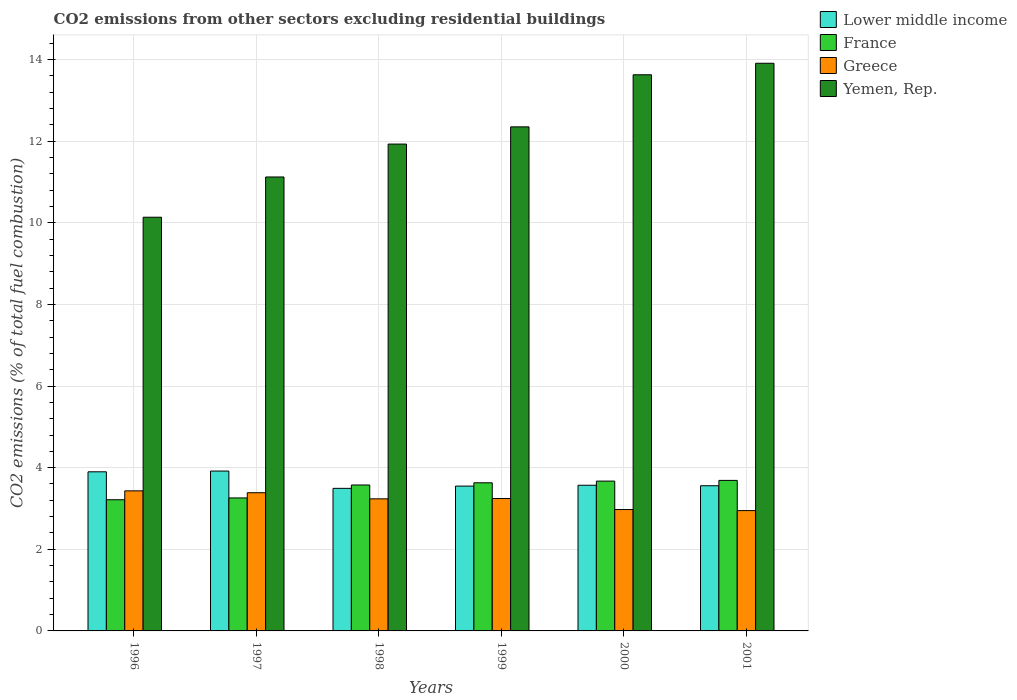How many groups of bars are there?
Keep it short and to the point. 6. Are the number of bars per tick equal to the number of legend labels?
Provide a succinct answer. Yes. How many bars are there on the 5th tick from the left?
Keep it short and to the point. 4. What is the total CO2 emitted in Yemen, Rep. in 2001?
Offer a terse response. 13.91. Across all years, what is the maximum total CO2 emitted in Yemen, Rep.?
Your answer should be very brief. 13.91. Across all years, what is the minimum total CO2 emitted in Greece?
Make the answer very short. 2.95. In which year was the total CO2 emitted in Yemen, Rep. maximum?
Your answer should be very brief. 2001. What is the total total CO2 emitted in Greece in the graph?
Your answer should be very brief. 19.22. What is the difference between the total CO2 emitted in Greece in 2000 and that in 2001?
Offer a terse response. 0.03. What is the difference between the total CO2 emitted in Greece in 2001 and the total CO2 emitted in France in 1999?
Offer a very short reply. -0.68. What is the average total CO2 emitted in Lower middle income per year?
Give a very brief answer. 3.66. In the year 2001, what is the difference between the total CO2 emitted in Greece and total CO2 emitted in France?
Your response must be concise. -0.74. What is the ratio of the total CO2 emitted in Lower middle income in 1999 to that in 2000?
Keep it short and to the point. 0.99. Is the difference between the total CO2 emitted in Greece in 1997 and 2001 greater than the difference between the total CO2 emitted in France in 1997 and 2001?
Provide a succinct answer. Yes. What is the difference between the highest and the second highest total CO2 emitted in Greece?
Your answer should be very brief. 0.05. What is the difference between the highest and the lowest total CO2 emitted in France?
Ensure brevity in your answer.  0.47. In how many years, is the total CO2 emitted in Yemen, Rep. greater than the average total CO2 emitted in Yemen, Rep. taken over all years?
Your answer should be compact. 3. Is the sum of the total CO2 emitted in France in 2000 and 2001 greater than the maximum total CO2 emitted in Yemen, Rep. across all years?
Your response must be concise. No. What does the 1st bar from the right in 1997 represents?
Provide a short and direct response. Yemen, Rep. How many bars are there?
Provide a short and direct response. 24. Are all the bars in the graph horizontal?
Your answer should be compact. No. How many years are there in the graph?
Your answer should be compact. 6. What is the difference between two consecutive major ticks on the Y-axis?
Ensure brevity in your answer.  2. Are the values on the major ticks of Y-axis written in scientific E-notation?
Provide a short and direct response. No. Does the graph contain any zero values?
Provide a succinct answer. No. Where does the legend appear in the graph?
Keep it short and to the point. Top right. How many legend labels are there?
Offer a terse response. 4. What is the title of the graph?
Offer a very short reply. CO2 emissions from other sectors excluding residential buildings. Does "Malaysia" appear as one of the legend labels in the graph?
Give a very brief answer. No. What is the label or title of the X-axis?
Make the answer very short. Years. What is the label or title of the Y-axis?
Your response must be concise. CO2 emissions (% of total fuel combustion). What is the CO2 emissions (% of total fuel combustion) of Lower middle income in 1996?
Ensure brevity in your answer.  3.9. What is the CO2 emissions (% of total fuel combustion) of France in 1996?
Your response must be concise. 3.21. What is the CO2 emissions (% of total fuel combustion) in Greece in 1996?
Give a very brief answer. 3.43. What is the CO2 emissions (% of total fuel combustion) in Yemen, Rep. in 1996?
Give a very brief answer. 10.14. What is the CO2 emissions (% of total fuel combustion) in Lower middle income in 1997?
Ensure brevity in your answer.  3.92. What is the CO2 emissions (% of total fuel combustion) of France in 1997?
Offer a very short reply. 3.26. What is the CO2 emissions (% of total fuel combustion) in Greece in 1997?
Provide a short and direct response. 3.39. What is the CO2 emissions (% of total fuel combustion) in Yemen, Rep. in 1997?
Keep it short and to the point. 11.12. What is the CO2 emissions (% of total fuel combustion) of Lower middle income in 1998?
Your answer should be compact. 3.49. What is the CO2 emissions (% of total fuel combustion) of France in 1998?
Provide a short and direct response. 3.58. What is the CO2 emissions (% of total fuel combustion) of Greece in 1998?
Keep it short and to the point. 3.24. What is the CO2 emissions (% of total fuel combustion) of Yemen, Rep. in 1998?
Offer a terse response. 11.93. What is the CO2 emissions (% of total fuel combustion) in Lower middle income in 1999?
Give a very brief answer. 3.55. What is the CO2 emissions (% of total fuel combustion) in France in 1999?
Your response must be concise. 3.63. What is the CO2 emissions (% of total fuel combustion) of Greece in 1999?
Your answer should be very brief. 3.24. What is the CO2 emissions (% of total fuel combustion) of Yemen, Rep. in 1999?
Offer a very short reply. 12.35. What is the CO2 emissions (% of total fuel combustion) in Lower middle income in 2000?
Provide a short and direct response. 3.57. What is the CO2 emissions (% of total fuel combustion) in France in 2000?
Make the answer very short. 3.67. What is the CO2 emissions (% of total fuel combustion) of Greece in 2000?
Your answer should be compact. 2.97. What is the CO2 emissions (% of total fuel combustion) in Yemen, Rep. in 2000?
Keep it short and to the point. 13.63. What is the CO2 emissions (% of total fuel combustion) of Lower middle income in 2001?
Provide a succinct answer. 3.56. What is the CO2 emissions (% of total fuel combustion) of France in 2001?
Keep it short and to the point. 3.69. What is the CO2 emissions (% of total fuel combustion) of Greece in 2001?
Your answer should be compact. 2.95. What is the CO2 emissions (% of total fuel combustion) of Yemen, Rep. in 2001?
Make the answer very short. 13.91. Across all years, what is the maximum CO2 emissions (% of total fuel combustion) in Lower middle income?
Give a very brief answer. 3.92. Across all years, what is the maximum CO2 emissions (% of total fuel combustion) of France?
Keep it short and to the point. 3.69. Across all years, what is the maximum CO2 emissions (% of total fuel combustion) in Greece?
Offer a very short reply. 3.43. Across all years, what is the maximum CO2 emissions (% of total fuel combustion) of Yemen, Rep.?
Your response must be concise. 13.91. Across all years, what is the minimum CO2 emissions (% of total fuel combustion) of Lower middle income?
Offer a very short reply. 3.49. Across all years, what is the minimum CO2 emissions (% of total fuel combustion) in France?
Keep it short and to the point. 3.21. Across all years, what is the minimum CO2 emissions (% of total fuel combustion) of Greece?
Offer a terse response. 2.95. Across all years, what is the minimum CO2 emissions (% of total fuel combustion) in Yemen, Rep.?
Ensure brevity in your answer.  10.14. What is the total CO2 emissions (% of total fuel combustion) of Lower middle income in the graph?
Provide a short and direct response. 21.98. What is the total CO2 emissions (% of total fuel combustion) in France in the graph?
Ensure brevity in your answer.  21.04. What is the total CO2 emissions (% of total fuel combustion) of Greece in the graph?
Offer a very short reply. 19.22. What is the total CO2 emissions (% of total fuel combustion) of Yemen, Rep. in the graph?
Ensure brevity in your answer.  73.07. What is the difference between the CO2 emissions (% of total fuel combustion) in Lower middle income in 1996 and that in 1997?
Give a very brief answer. -0.02. What is the difference between the CO2 emissions (% of total fuel combustion) of France in 1996 and that in 1997?
Provide a succinct answer. -0.04. What is the difference between the CO2 emissions (% of total fuel combustion) of Greece in 1996 and that in 1997?
Ensure brevity in your answer.  0.05. What is the difference between the CO2 emissions (% of total fuel combustion) of Yemen, Rep. in 1996 and that in 1997?
Ensure brevity in your answer.  -0.99. What is the difference between the CO2 emissions (% of total fuel combustion) in Lower middle income in 1996 and that in 1998?
Make the answer very short. 0.41. What is the difference between the CO2 emissions (% of total fuel combustion) of France in 1996 and that in 1998?
Keep it short and to the point. -0.36. What is the difference between the CO2 emissions (% of total fuel combustion) in Greece in 1996 and that in 1998?
Make the answer very short. 0.2. What is the difference between the CO2 emissions (% of total fuel combustion) in Yemen, Rep. in 1996 and that in 1998?
Make the answer very short. -1.79. What is the difference between the CO2 emissions (% of total fuel combustion) in Lower middle income in 1996 and that in 1999?
Offer a very short reply. 0.35. What is the difference between the CO2 emissions (% of total fuel combustion) of France in 1996 and that in 1999?
Keep it short and to the point. -0.42. What is the difference between the CO2 emissions (% of total fuel combustion) in Greece in 1996 and that in 1999?
Keep it short and to the point. 0.19. What is the difference between the CO2 emissions (% of total fuel combustion) in Yemen, Rep. in 1996 and that in 1999?
Provide a succinct answer. -2.21. What is the difference between the CO2 emissions (% of total fuel combustion) in Lower middle income in 1996 and that in 2000?
Keep it short and to the point. 0.33. What is the difference between the CO2 emissions (% of total fuel combustion) in France in 1996 and that in 2000?
Make the answer very short. -0.46. What is the difference between the CO2 emissions (% of total fuel combustion) of Greece in 1996 and that in 2000?
Provide a short and direct response. 0.46. What is the difference between the CO2 emissions (% of total fuel combustion) of Yemen, Rep. in 1996 and that in 2000?
Ensure brevity in your answer.  -3.49. What is the difference between the CO2 emissions (% of total fuel combustion) of Lower middle income in 1996 and that in 2001?
Your response must be concise. 0.34. What is the difference between the CO2 emissions (% of total fuel combustion) in France in 1996 and that in 2001?
Keep it short and to the point. -0.47. What is the difference between the CO2 emissions (% of total fuel combustion) of Greece in 1996 and that in 2001?
Offer a very short reply. 0.48. What is the difference between the CO2 emissions (% of total fuel combustion) in Yemen, Rep. in 1996 and that in 2001?
Provide a short and direct response. -3.77. What is the difference between the CO2 emissions (% of total fuel combustion) in Lower middle income in 1997 and that in 1998?
Your answer should be very brief. 0.42. What is the difference between the CO2 emissions (% of total fuel combustion) in France in 1997 and that in 1998?
Offer a terse response. -0.32. What is the difference between the CO2 emissions (% of total fuel combustion) in Greece in 1997 and that in 1998?
Keep it short and to the point. 0.15. What is the difference between the CO2 emissions (% of total fuel combustion) in Yemen, Rep. in 1997 and that in 1998?
Provide a succinct answer. -0.81. What is the difference between the CO2 emissions (% of total fuel combustion) of Lower middle income in 1997 and that in 1999?
Your answer should be compact. 0.37. What is the difference between the CO2 emissions (% of total fuel combustion) in France in 1997 and that in 1999?
Ensure brevity in your answer.  -0.37. What is the difference between the CO2 emissions (% of total fuel combustion) in Greece in 1997 and that in 1999?
Keep it short and to the point. 0.14. What is the difference between the CO2 emissions (% of total fuel combustion) of Yemen, Rep. in 1997 and that in 1999?
Your answer should be compact. -1.23. What is the difference between the CO2 emissions (% of total fuel combustion) in Lower middle income in 1997 and that in 2000?
Give a very brief answer. 0.35. What is the difference between the CO2 emissions (% of total fuel combustion) in France in 1997 and that in 2000?
Give a very brief answer. -0.41. What is the difference between the CO2 emissions (% of total fuel combustion) of Greece in 1997 and that in 2000?
Give a very brief answer. 0.41. What is the difference between the CO2 emissions (% of total fuel combustion) in Yemen, Rep. in 1997 and that in 2000?
Your answer should be very brief. -2.5. What is the difference between the CO2 emissions (% of total fuel combustion) in Lower middle income in 1997 and that in 2001?
Make the answer very short. 0.36. What is the difference between the CO2 emissions (% of total fuel combustion) in France in 1997 and that in 2001?
Provide a succinct answer. -0.43. What is the difference between the CO2 emissions (% of total fuel combustion) of Greece in 1997 and that in 2001?
Offer a very short reply. 0.44. What is the difference between the CO2 emissions (% of total fuel combustion) in Yemen, Rep. in 1997 and that in 2001?
Give a very brief answer. -2.79. What is the difference between the CO2 emissions (% of total fuel combustion) in Lower middle income in 1998 and that in 1999?
Provide a succinct answer. -0.06. What is the difference between the CO2 emissions (% of total fuel combustion) of France in 1998 and that in 1999?
Ensure brevity in your answer.  -0.05. What is the difference between the CO2 emissions (% of total fuel combustion) of Greece in 1998 and that in 1999?
Give a very brief answer. -0.01. What is the difference between the CO2 emissions (% of total fuel combustion) of Yemen, Rep. in 1998 and that in 1999?
Provide a short and direct response. -0.42. What is the difference between the CO2 emissions (% of total fuel combustion) in Lower middle income in 1998 and that in 2000?
Provide a succinct answer. -0.08. What is the difference between the CO2 emissions (% of total fuel combustion) in France in 1998 and that in 2000?
Keep it short and to the point. -0.1. What is the difference between the CO2 emissions (% of total fuel combustion) of Greece in 1998 and that in 2000?
Your response must be concise. 0.26. What is the difference between the CO2 emissions (% of total fuel combustion) of Yemen, Rep. in 1998 and that in 2000?
Provide a succinct answer. -1.7. What is the difference between the CO2 emissions (% of total fuel combustion) of Lower middle income in 1998 and that in 2001?
Give a very brief answer. -0.06. What is the difference between the CO2 emissions (% of total fuel combustion) in France in 1998 and that in 2001?
Offer a terse response. -0.11. What is the difference between the CO2 emissions (% of total fuel combustion) of Greece in 1998 and that in 2001?
Offer a terse response. 0.29. What is the difference between the CO2 emissions (% of total fuel combustion) of Yemen, Rep. in 1998 and that in 2001?
Offer a terse response. -1.98. What is the difference between the CO2 emissions (% of total fuel combustion) of Lower middle income in 1999 and that in 2000?
Offer a very short reply. -0.02. What is the difference between the CO2 emissions (% of total fuel combustion) in France in 1999 and that in 2000?
Your answer should be very brief. -0.04. What is the difference between the CO2 emissions (% of total fuel combustion) of Greece in 1999 and that in 2000?
Your answer should be very brief. 0.27. What is the difference between the CO2 emissions (% of total fuel combustion) of Yemen, Rep. in 1999 and that in 2000?
Your response must be concise. -1.28. What is the difference between the CO2 emissions (% of total fuel combustion) of Lower middle income in 1999 and that in 2001?
Make the answer very short. -0.01. What is the difference between the CO2 emissions (% of total fuel combustion) in France in 1999 and that in 2001?
Keep it short and to the point. -0.06. What is the difference between the CO2 emissions (% of total fuel combustion) of Greece in 1999 and that in 2001?
Your answer should be compact. 0.3. What is the difference between the CO2 emissions (% of total fuel combustion) in Yemen, Rep. in 1999 and that in 2001?
Your answer should be compact. -1.56. What is the difference between the CO2 emissions (% of total fuel combustion) of Lower middle income in 2000 and that in 2001?
Provide a succinct answer. 0.01. What is the difference between the CO2 emissions (% of total fuel combustion) in France in 2000 and that in 2001?
Give a very brief answer. -0.02. What is the difference between the CO2 emissions (% of total fuel combustion) of Greece in 2000 and that in 2001?
Give a very brief answer. 0.03. What is the difference between the CO2 emissions (% of total fuel combustion) of Yemen, Rep. in 2000 and that in 2001?
Ensure brevity in your answer.  -0.28. What is the difference between the CO2 emissions (% of total fuel combustion) in Lower middle income in 1996 and the CO2 emissions (% of total fuel combustion) in France in 1997?
Offer a very short reply. 0.64. What is the difference between the CO2 emissions (% of total fuel combustion) in Lower middle income in 1996 and the CO2 emissions (% of total fuel combustion) in Greece in 1997?
Your answer should be very brief. 0.51. What is the difference between the CO2 emissions (% of total fuel combustion) of Lower middle income in 1996 and the CO2 emissions (% of total fuel combustion) of Yemen, Rep. in 1997?
Ensure brevity in your answer.  -7.22. What is the difference between the CO2 emissions (% of total fuel combustion) in France in 1996 and the CO2 emissions (% of total fuel combustion) in Greece in 1997?
Keep it short and to the point. -0.17. What is the difference between the CO2 emissions (% of total fuel combustion) in France in 1996 and the CO2 emissions (% of total fuel combustion) in Yemen, Rep. in 1997?
Make the answer very short. -7.91. What is the difference between the CO2 emissions (% of total fuel combustion) in Greece in 1996 and the CO2 emissions (% of total fuel combustion) in Yemen, Rep. in 1997?
Ensure brevity in your answer.  -7.69. What is the difference between the CO2 emissions (% of total fuel combustion) of Lower middle income in 1996 and the CO2 emissions (% of total fuel combustion) of France in 1998?
Provide a succinct answer. 0.32. What is the difference between the CO2 emissions (% of total fuel combustion) in Lower middle income in 1996 and the CO2 emissions (% of total fuel combustion) in Greece in 1998?
Ensure brevity in your answer.  0.66. What is the difference between the CO2 emissions (% of total fuel combustion) in Lower middle income in 1996 and the CO2 emissions (% of total fuel combustion) in Yemen, Rep. in 1998?
Your response must be concise. -8.03. What is the difference between the CO2 emissions (% of total fuel combustion) of France in 1996 and the CO2 emissions (% of total fuel combustion) of Greece in 1998?
Your answer should be compact. -0.02. What is the difference between the CO2 emissions (% of total fuel combustion) in France in 1996 and the CO2 emissions (% of total fuel combustion) in Yemen, Rep. in 1998?
Offer a very short reply. -8.71. What is the difference between the CO2 emissions (% of total fuel combustion) of Greece in 1996 and the CO2 emissions (% of total fuel combustion) of Yemen, Rep. in 1998?
Your answer should be compact. -8.5. What is the difference between the CO2 emissions (% of total fuel combustion) in Lower middle income in 1996 and the CO2 emissions (% of total fuel combustion) in France in 1999?
Keep it short and to the point. 0.27. What is the difference between the CO2 emissions (% of total fuel combustion) in Lower middle income in 1996 and the CO2 emissions (% of total fuel combustion) in Greece in 1999?
Provide a succinct answer. 0.65. What is the difference between the CO2 emissions (% of total fuel combustion) in Lower middle income in 1996 and the CO2 emissions (% of total fuel combustion) in Yemen, Rep. in 1999?
Ensure brevity in your answer.  -8.45. What is the difference between the CO2 emissions (% of total fuel combustion) of France in 1996 and the CO2 emissions (% of total fuel combustion) of Greece in 1999?
Keep it short and to the point. -0.03. What is the difference between the CO2 emissions (% of total fuel combustion) of France in 1996 and the CO2 emissions (% of total fuel combustion) of Yemen, Rep. in 1999?
Provide a succinct answer. -9.14. What is the difference between the CO2 emissions (% of total fuel combustion) of Greece in 1996 and the CO2 emissions (% of total fuel combustion) of Yemen, Rep. in 1999?
Offer a very short reply. -8.92. What is the difference between the CO2 emissions (% of total fuel combustion) of Lower middle income in 1996 and the CO2 emissions (% of total fuel combustion) of France in 2000?
Provide a succinct answer. 0.23. What is the difference between the CO2 emissions (% of total fuel combustion) in Lower middle income in 1996 and the CO2 emissions (% of total fuel combustion) in Greece in 2000?
Give a very brief answer. 0.92. What is the difference between the CO2 emissions (% of total fuel combustion) in Lower middle income in 1996 and the CO2 emissions (% of total fuel combustion) in Yemen, Rep. in 2000?
Keep it short and to the point. -9.73. What is the difference between the CO2 emissions (% of total fuel combustion) in France in 1996 and the CO2 emissions (% of total fuel combustion) in Greece in 2000?
Keep it short and to the point. 0.24. What is the difference between the CO2 emissions (% of total fuel combustion) of France in 1996 and the CO2 emissions (% of total fuel combustion) of Yemen, Rep. in 2000?
Provide a short and direct response. -10.41. What is the difference between the CO2 emissions (% of total fuel combustion) of Greece in 1996 and the CO2 emissions (% of total fuel combustion) of Yemen, Rep. in 2000?
Give a very brief answer. -10.19. What is the difference between the CO2 emissions (% of total fuel combustion) in Lower middle income in 1996 and the CO2 emissions (% of total fuel combustion) in France in 2001?
Your response must be concise. 0.21. What is the difference between the CO2 emissions (% of total fuel combustion) in Lower middle income in 1996 and the CO2 emissions (% of total fuel combustion) in Greece in 2001?
Keep it short and to the point. 0.95. What is the difference between the CO2 emissions (% of total fuel combustion) of Lower middle income in 1996 and the CO2 emissions (% of total fuel combustion) of Yemen, Rep. in 2001?
Give a very brief answer. -10.01. What is the difference between the CO2 emissions (% of total fuel combustion) in France in 1996 and the CO2 emissions (% of total fuel combustion) in Greece in 2001?
Your answer should be very brief. 0.27. What is the difference between the CO2 emissions (% of total fuel combustion) in France in 1996 and the CO2 emissions (% of total fuel combustion) in Yemen, Rep. in 2001?
Provide a short and direct response. -10.69. What is the difference between the CO2 emissions (% of total fuel combustion) of Greece in 1996 and the CO2 emissions (% of total fuel combustion) of Yemen, Rep. in 2001?
Keep it short and to the point. -10.48. What is the difference between the CO2 emissions (% of total fuel combustion) in Lower middle income in 1997 and the CO2 emissions (% of total fuel combustion) in France in 1998?
Provide a succinct answer. 0.34. What is the difference between the CO2 emissions (% of total fuel combustion) in Lower middle income in 1997 and the CO2 emissions (% of total fuel combustion) in Greece in 1998?
Make the answer very short. 0.68. What is the difference between the CO2 emissions (% of total fuel combustion) in Lower middle income in 1997 and the CO2 emissions (% of total fuel combustion) in Yemen, Rep. in 1998?
Give a very brief answer. -8.01. What is the difference between the CO2 emissions (% of total fuel combustion) in France in 1997 and the CO2 emissions (% of total fuel combustion) in Greece in 1998?
Ensure brevity in your answer.  0.02. What is the difference between the CO2 emissions (% of total fuel combustion) of France in 1997 and the CO2 emissions (% of total fuel combustion) of Yemen, Rep. in 1998?
Give a very brief answer. -8.67. What is the difference between the CO2 emissions (% of total fuel combustion) of Greece in 1997 and the CO2 emissions (% of total fuel combustion) of Yemen, Rep. in 1998?
Provide a succinct answer. -8.54. What is the difference between the CO2 emissions (% of total fuel combustion) in Lower middle income in 1997 and the CO2 emissions (% of total fuel combustion) in France in 1999?
Make the answer very short. 0.29. What is the difference between the CO2 emissions (% of total fuel combustion) in Lower middle income in 1997 and the CO2 emissions (% of total fuel combustion) in Greece in 1999?
Offer a very short reply. 0.67. What is the difference between the CO2 emissions (% of total fuel combustion) of Lower middle income in 1997 and the CO2 emissions (% of total fuel combustion) of Yemen, Rep. in 1999?
Ensure brevity in your answer.  -8.43. What is the difference between the CO2 emissions (% of total fuel combustion) in France in 1997 and the CO2 emissions (% of total fuel combustion) in Greece in 1999?
Your answer should be very brief. 0.01. What is the difference between the CO2 emissions (% of total fuel combustion) of France in 1997 and the CO2 emissions (% of total fuel combustion) of Yemen, Rep. in 1999?
Provide a succinct answer. -9.09. What is the difference between the CO2 emissions (% of total fuel combustion) of Greece in 1997 and the CO2 emissions (% of total fuel combustion) of Yemen, Rep. in 1999?
Give a very brief answer. -8.96. What is the difference between the CO2 emissions (% of total fuel combustion) of Lower middle income in 1997 and the CO2 emissions (% of total fuel combustion) of France in 2000?
Your answer should be very brief. 0.25. What is the difference between the CO2 emissions (% of total fuel combustion) in Lower middle income in 1997 and the CO2 emissions (% of total fuel combustion) in Greece in 2000?
Give a very brief answer. 0.94. What is the difference between the CO2 emissions (% of total fuel combustion) in Lower middle income in 1997 and the CO2 emissions (% of total fuel combustion) in Yemen, Rep. in 2000?
Ensure brevity in your answer.  -9.71. What is the difference between the CO2 emissions (% of total fuel combustion) in France in 1997 and the CO2 emissions (% of total fuel combustion) in Greece in 2000?
Make the answer very short. 0.28. What is the difference between the CO2 emissions (% of total fuel combustion) of France in 1997 and the CO2 emissions (% of total fuel combustion) of Yemen, Rep. in 2000?
Make the answer very short. -10.37. What is the difference between the CO2 emissions (% of total fuel combustion) of Greece in 1997 and the CO2 emissions (% of total fuel combustion) of Yemen, Rep. in 2000?
Your answer should be compact. -10.24. What is the difference between the CO2 emissions (% of total fuel combustion) in Lower middle income in 1997 and the CO2 emissions (% of total fuel combustion) in France in 2001?
Provide a short and direct response. 0.23. What is the difference between the CO2 emissions (% of total fuel combustion) in Lower middle income in 1997 and the CO2 emissions (% of total fuel combustion) in Greece in 2001?
Give a very brief answer. 0.97. What is the difference between the CO2 emissions (% of total fuel combustion) of Lower middle income in 1997 and the CO2 emissions (% of total fuel combustion) of Yemen, Rep. in 2001?
Provide a short and direct response. -9.99. What is the difference between the CO2 emissions (% of total fuel combustion) in France in 1997 and the CO2 emissions (% of total fuel combustion) in Greece in 2001?
Provide a succinct answer. 0.31. What is the difference between the CO2 emissions (% of total fuel combustion) of France in 1997 and the CO2 emissions (% of total fuel combustion) of Yemen, Rep. in 2001?
Offer a terse response. -10.65. What is the difference between the CO2 emissions (% of total fuel combustion) of Greece in 1997 and the CO2 emissions (% of total fuel combustion) of Yemen, Rep. in 2001?
Provide a succinct answer. -10.52. What is the difference between the CO2 emissions (% of total fuel combustion) of Lower middle income in 1998 and the CO2 emissions (% of total fuel combustion) of France in 1999?
Keep it short and to the point. -0.14. What is the difference between the CO2 emissions (% of total fuel combustion) of Lower middle income in 1998 and the CO2 emissions (% of total fuel combustion) of Greece in 1999?
Make the answer very short. 0.25. What is the difference between the CO2 emissions (% of total fuel combustion) in Lower middle income in 1998 and the CO2 emissions (% of total fuel combustion) in Yemen, Rep. in 1999?
Offer a terse response. -8.86. What is the difference between the CO2 emissions (% of total fuel combustion) in France in 1998 and the CO2 emissions (% of total fuel combustion) in Greece in 1999?
Your answer should be very brief. 0.33. What is the difference between the CO2 emissions (% of total fuel combustion) in France in 1998 and the CO2 emissions (% of total fuel combustion) in Yemen, Rep. in 1999?
Keep it short and to the point. -8.77. What is the difference between the CO2 emissions (% of total fuel combustion) in Greece in 1998 and the CO2 emissions (% of total fuel combustion) in Yemen, Rep. in 1999?
Offer a terse response. -9.11. What is the difference between the CO2 emissions (% of total fuel combustion) in Lower middle income in 1998 and the CO2 emissions (% of total fuel combustion) in France in 2000?
Keep it short and to the point. -0.18. What is the difference between the CO2 emissions (% of total fuel combustion) in Lower middle income in 1998 and the CO2 emissions (% of total fuel combustion) in Greece in 2000?
Provide a short and direct response. 0.52. What is the difference between the CO2 emissions (% of total fuel combustion) in Lower middle income in 1998 and the CO2 emissions (% of total fuel combustion) in Yemen, Rep. in 2000?
Give a very brief answer. -10.13. What is the difference between the CO2 emissions (% of total fuel combustion) in France in 1998 and the CO2 emissions (% of total fuel combustion) in Greece in 2000?
Your answer should be compact. 0.6. What is the difference between the CO2 emissions (% of total fuel combustion) of France in 1998 and the CO2 emissions (% of total fuel combustion) of Yemen, Rep. in 2000?
Offer a terse response. -10.05. What is the difference between the CO2 emissions (% of total fuel combustion) of Greece in 1998 and the CO2 emissions (% of total fuel combustion) of Yemen, Rep. in 2000?
Your answer should be very brief. -10.39. What is the difference between the CO2 emissions (% of total fuel combustion) in Lower middle income in 1998 and the CO2 emissions (% of total fuel combustion) in France in 2001?
Your answer should be very brief. -0.19. What is the difference between the CO2 emissions (% of total fuel combustion) of Lower middle income in 1998 and the CO2 emissions (% of total fuel combustion) of Greece in 2001?
Keep it short and to the point. 0.55. What is the difference between the CO2 emissions (% of total fuel combustion) in Lower middle income in 1998 and the CO2 emissions (% of total fuel combustion) in Yemen, Rep. in 2001?
Ensure brevity in your answer.  -10.42. What is the difference between the CO2 emissions (% of total fuel combustion) of France in 1998 and the CO2 emissions (% of total fuel combustion) of Greece in 2001?
Make the answer very short. 0.63. What is the difference between the CO2 emissions (% of total fuel combustion) in France in 1998 and the CO2 emissions (% of total fuel combustion) in Yemen, Rep. in 2001?
Give a very brief answer. -10.33. What is the difference between the CO2 emissions (% of total fuel combustion) in Greece in 1998 and the CO2 emissions (% of total fuel combustion) in Yemen, Rep. in 2001?
Give a very brief answer. -10.67. What is the difference between the CO2 emissions (% of total fuel combustion) of Lower middle income in 1999 and the CO2 emissions (% of total fuel combustion) of France in 2000?
Ensure brevity in your answer.  -0.12. What is the difference between the CO2 emissions (% of total fuel combustion) of Lower middle income in 1999 and the CO2 emissions (% of total fuel combustion) of Greece in 2000?
Offer a very short reply. 0.57. What is the difference between the CO2 emissions (% of total fuel combustion) of Lower middle income in 1999 and the CO2 emissions (% of total fuel combustion) of Yemen, Rep. in 2000?
Provide a short and direct response. -10.08. What is the difference between the CO2 emissions (% of total fuel combustion) of France in 1999 and the CO2 emissions (% of total fuel combustion) of Greece in 2000?
Your answer should be compact. 0.66. What is the difference between the CO2 emissions (% of total fuel combustion) of France in 1999 and the CO2 emissions (% of total fuel combustion) of Yemen, Rep. in 2000?
Give a very brief answer. -10. What is the difference between the CO2 emissions (% of total fuel combustion) of Greece in 1999 and the CO2 emissions (% of total fuel combustion) of Yemen, Rep. in 2000?
Keep it short and to the point. -10.38. What is the difference between the CO2 emissions (% of total fuel combustion) in Lower middle income in 1999 and the CO2 emissions (% of total fuel combustion) in France in 2001?
Provide a short and direct response. -0.14. What is the difference between the CO2 emissions (% of total fuel combustion) in Lower middle income in 1999 and the CO2 emissions (% of total fuel combustion) in Greece in 2001?
Offer a terse response. 0.6. What is the difference between the CO2 emissions (% of total fuel combustion) in Lower middle income in 1999 and the CO2 emissions (% of total fuel combustion) in Yemen, Rep. in 2001?
Offer a terse response. -10.36. What is the difference between the CO2 emissions (% of total fuel combustion) in France in 1999 and the CO2 emissions (% of total fuel combustion) in Greece in 2001?
Give a very brief answer. 0.68. What is the difference between the CO2 emissions (% of total fuel combustion) of France in 1999 and the CO2 emissions (% of total fuel combustion) of Yemen, Rep. in 2001?
Keep it short and to the point. -10.28. What is the difference between the CO2 emissions (% of total fuel combustion) of Greece in 1999 and the CO2 emissions (% of total fuel combustion) of Yemen, Rep. in 2001?
Your answer should be very brief. -10.66. What is the difference between the CO2 emissions (% of total fuel combustion) of Lower middle income in 2000 and the CO2 emissions (% of total fuel combustion) of France in 2001?
Offer a terse response. -0.12. What is the difference between the CO2 emissions (% of total fuel combustion) in Lower middle income in 2000 and the CO2 emissions (% of total fuel combustion) in Greece in 2001?
Offer a terse response. 0.62. What is the difference between the CO2 emissions (% of total fuel combustion) in Lower middle income in 2000 and the CO2 emissions (% of total fuel combustion) in Yemen, Rep. in 2001?
Make the answer very short. -10.34. What is the difference between the CO2 emissions (% of total fuel combustion) of France in 2000 and the CO2 emissions (% of total fuel combustion) of Greece in 2001?
Ensure brevity in your answer.  0.72. What is the difference between the CO2 emissions (% of total fuel combustion) of France in 2000 and the CO2 emissions (% of total fuel combustion) of Yemen, Rep. in 2001?
Offer a very short reply. -10.24. What is the difference between the CO2 emissions (% of total fuel combustion) in Greece in 2000 and the CO2 emissions (% of total fuel combustion) in Yemen, Rep. in 2001?
Your response must be concise. -10.93. What is the average CO2 emissions (% of total fuel combustion) in Lower middle income per year?
Give a very brief answer. 3.66. What is the average CO2 emissions (% of total fuel combustion) of France per year?
Offer a terse response. 3.51. What is the average CO2 emissions (% of total fuel combustion) of Greece per year?
Ensure brevity in your answer.  3.2. What is the average CO2 emissions (% of total fuel combustion) of Yemen, Rep. per year?
Offer a very short reply. 12.18. In the year 1996, what is the difference between the CO2 emissions (% of total fuel combustion) of Lower middle income and CO2 emissions (% of total fuel combustion) of France?
Make the answer very short. 0.68. In the year 1996, what is the difference between the CO2 emissions (% of total fuel combustion) in Lower middle income and CO2 emissions (% of total fuel combustion) in Greece?
Provide a short and direct response. 0.47. In the year 1996, what is the difference between the CO2 emissions (% of total fuel combustion) in Lower middle income and CO2 emissions (% of total fuel combustion) in Yemen, Rep.?
Give a very brief answer. -6.24. In the year 1996, what is the difference between the CO2 emissions (% of total fuel combustion) in France and CO2 emissions (% of total fuel combustion) in Greece?
Provide a short and direct response. -0.22. In the year 1996, what is the difference between the CO2 emissions (% of total fuel combustion) in France and CO2 emissions (% of total fuel combustion) in Yemen, Rep.?
Give a very brief answer. -6.92. In the year 1996, what is the difference between the CO2 emissions (% of total fuel combustion) in Greece and CO2 emissions (% of total fuel combustion) in Yemen, Rep.?
Offer a very short reply. -6.7. In the year 1997, what is the difference between the CO2 emissions (% of total fuel combustion) of Lower middle income and CO2 emissions (% of total fuel combustion) of France?
Your answer should be compact. 0.66. In the year 1997, what is the difference between the CO2 emissions (% of total fuel combustion) in Lower middle income and CO2 emissions (% of total fuel combustion) in Greece?
Give a very brief answer. 0.53. In the year 1997, what is the difference between the CO2 emissions (% of total fuel combustion) of Lower middle income and CO2 emissions (% of total fuel combustion) of Yemen, Rep.?
Provide a succinct answer. -7.21. In the year 1997, what is the difference between the CO2 emissions (% of total fuel combustion) in France and CO2 emissions (% of total fuel combustion) in Greece?
Offer a very short reply. -0.13. In the year 1997, what is the difference between the CO2 emissions (% of total fuel combustion) in France and CO2 emissions (% of total fuel combustion) in Yemen, Rep.?
Make the answer very short. -7.86. In the year 1997, what is the difference between the CO2 emissions (% of total fuel combustion) in Greece and CO2 emissions (% of total fuel combustion) in Yemen, Rep.?
Offer a terse response. -7.74. In the year 1998, what is the difference between the CO2 emissions (% of total fuel combustion) in Lower middle income and CO2 emissions (% of total fuel combustion) in France?
Give a very brief answer. -0.08. In the year 1998, what is the difference between the CO2 emissions (% of total fuel combustion) of Lower middle income and CO2 emissions (% of total fuel combustion) of Greece?
Your response must be concise. 0.26. In the year 1998, what is the difference between the CO2 emissions (% of total fuel combustion) of Lower middle income and CO2 emissions (% of total fuel combustion) of Yemen, Rep.?
Offer a terse response. -8.44. In the year 1998, what is the difference between the CO2 emissions (% of total fuel combustion) in France and CO2 emissions (% of total fuel combustion) in Greece?
Your answer should be compact. 0.34. In the year 1998, what is the difference between the CO2 emissions (% of total fuel combustion) of France and CO2 emissions (% of total fuel combustion) of Yemen, Rep.?
Provide a succinct answer. -8.35. In the year 1998, what is the difference between the CO2 emissions (% of total fuel combustion) of Greece and CO2 emissions (% of total fuel combustion) of Yemen, Rep.?
Make the answer very short. -8.69. In the year 1999, what is the difference between the CO2 emissions (% of total fuel combustion) of Lower middle income and CO2 emissions (% of total fuel combustion) of France?
Provide a short and direct response. -0.08. In the year 1999, what is the difference between the CO2 emissions (% of total fuel combustion) of Lower middle income and CO2 emissions (% of total fuel combustion) of Greece?
Ensure brevity in your answer.  0.3. In the year 1999, what is the difference between the CO2 emissions (% of total fuel combustion) in Lower middle income and CO2 emissions (% of total fuel combustion) in Yemen, Rep.?
Your answer should be compact. -8.8. In the year 1999, what is the difference between the CO2 emissions (% of total fuel combustion) in France and CO2 emissions (% of total fuel combustion) in Greece?
Provide a short and direct response. 0.39. In the year 1999, what is the difference between the CO2 emissions (% of total fuel combustion) in France and CO2 emissions (% of total fuel combustion) in Yemen, Rep.?
Your answer should be compact. -8.72. In the year 1999, what is the difference between the CO2 emissions (% of total fuel combustion) in Greece and CO2 emissions (% of total fuel combustion) in Yemen, Rep.?
Give a very brief answer. -9.11. In the year 2000, what is the difference between the CO2 emissions (% of total fuel combustion) in Lower middle income and CO2 emissions (% of total fuel combustion) in France?
Provide a succinct answer. -0.1. In the year 2000, what is the difference between the CO2 emissions (% of total fuel combustion) in Lower middle income and CO2 emissions (% of total fuel combustion) in Greece?
Your answer should be compact. 0.6. In the year 2000, what is the difference between the CO2 emissions (% of total fuel combustion) of Lower middle income and CO2 emissions (% of total fuel combustion) of Yemen, Rep.?
Your response must be concise. -10.06. In the year 2000, what is the difference between the CO2 emissions (% of total fuel combustion) of France and CO2 emissions (% of total fuel combustion) of Greece?
Offer a very short reply. 0.7. In the year 2000, what is the difference between the CO2 emissions (% of total fuel combustion) of France and CO2 emissions (% of total fuel combustion) of Yemen, Rep.?
Your answer should be compact. -9.96. In the year 2000, what is the difference between the CO2 emissions (% of total fuel combustion) in Greece and CO2 emissions (% of total fuel combustion) in Yemen, Rep.?
Offer a terse response. -10.65. In the year 2001, what is the difference between the CO2 emissions (% of total fuel combustion) in Lower middle income and CO2 emissions (% of total fuel combustion) in France?
Your answer should be very brief. -0.13. In the year 2001, what is the difference between the CO2 emissions (% of total fuel combustion) of Lower middle income and CO2 emissions (% of total fuel combustion) of Greece?
Offer a terse response. 0.61. In the year 2001, what is the difference between the CO2 emissions (% of total fuel combustion) of Lower middle income and CO2 emissions (% of total fuel combustion) of Yemen, Rep.?
Ensure brevity in your answer.  -10.35. In the year 2001, what is the difference between the CO2 emissions (% of total fuel combustion) of France and CO2 emissions (% of total fuel combustion) of Greece?
Offer a very short reply. 0.74. In the year 2001, what is the difference between the CO2 emissions (% of total fuel combustion) in France and CO2 emissions (% of total fuel combustion) in Yemen, Rep.?
Provide a short and direct response. -10.22. In the year 2001, what is the difference between the CO2 emissions (% of total fuel combustion) in Greece and CO2 emissions (% of total fuel combustion) in Yemen, Rep.?
Your answer should be compact. -10.96. What is the ratio of the CO2 emissions (% of total fuel combustion) in Lower middle income in 1996 to that in 1997?
Your response must be concise. 1. What is the ratio of the CO2 emissions (% of total fuel combustion) in France in 1996 to that in 1997?
Offer a very short reply. 0.99. What is the ratio of the CO2 emissions (% of total fuel combustion) of Greece in 1996 to that in 1997?
Your answer should be very brief. 1.01. What is the ratio of the CO2 emissions (% of total fuel combustion) in Yemen, Rep. in 1996 to that in 1997?
Your response must be concise. 0.91. What is the ratio of the CO2 emissions (% of total fuel combustion) of Lower middle income in 1996 to that in 1998?
Your answer should be very brief. 1.12. What is the ratio of the CO2 emissions (% of total fuel combustion) in France in 1996 to that in 1998?
Provide a short and direct response. 0.9. What is the ratio of the CO2 emissions (% of total fuel combustion) of Greece in 1996 to that in 1998?
Make the answer very short. 1.06. What is the ratio of the CO2 emissions (% of total fuel combustion) in Yemen, Rep. in 1996 to that in 1998?
Make the answer very short. 0.85. What is the ratio of the CO2 emissions (% of total fuel combustion) of Lower middle income in 1996 to that in 1999?
Offer a very short reply. 1.1. What is the ratio of the CO2 emissions (% of total fuel combustion) of France in 1996 to that in 1999?
Give a very brief answer. 0.89. What is the ratio of the CO2 emissions (% of total fuel combustion) in Greece in 1996 to that in 1999?
Give a very brief answer. 1.06. What is the ratio of the CO2 emissions (% of total fuel combustion) of Yemen, Rep. in 1996 to that in 1999?
Your answer should be compact. 0.82. What is the ratio of the CO2 emissions (% of total fuel combustion) in Lower middle income in 1996 to that in 2000?
Make the answer very short. 1.09. What is the ratio of the CO2 emissions (% of total fuel combustion) of France in 1996 to that in 2000?
Provide a short and direct response. 0.88. What is the ratio of the CO2 emissions (% of total fuel combustion) in Greece in 1996 to that in 2000?
Your answer should be compact. 1.15. What is the ratio of the CO2 emissions (% of total fuel combustion) in Yemen, Rep. in 1996 to that in 2000?
Your answer should be very brief. 0.74. What is the ratio of the CO2 emissions (% of total fuel combustion) of Lower middle income in 1996 to that in 2001?
Your response must be concise. 1.1. What is the ratio of the CO2 emissions (% of total fuel combustion) in France in 1996 to that in 2001?
Keep it short and to the point. 0.87. What is the ratio of the CO2 emissions (% of total fuel combustion) of Greece in 1996 to that in 2001?
Make the answer very short. 1.16. What is the ratio of the CO2 emissions (% of total fuel combustion) in Yemen, Rep. in 1996 to that in 2001?
Offer a terse response. 0.73. What is the ratio of the CO2 emissions (% of total fuel combustion) in Lower middle income in 1997 to that in 1998?
Make the answer very short. 1.12. What is the ratio of the CO2 emissions (% of total fuel combustion) in France in 1997 to that in 1998?
Offer a very short reply. 0.91. What is the ratio of the CO2 emissions (% of total fuel combustion) in Greece in 1997 to that in 1998?
Ensure brevity in your answer.  1.05. What is the ratio of the CO2 emissions (% of total fuel combustion) in Yemen, Rep. in 1997 to that in 1998?
Provide a short and direct response. 0.93. What is the ratio of the CO2 emissions (% of total fuel combustion) of Lower middle income in 1997 to that in 1999?
Keep it short and to the point. 1.1. What is the ratio of the CO2 emissions (% of total fuel combustion) in France in 1997 to that in 1999?
Your response must be concise. 0.9. What is the ratio of the CO2 emissions (% of total fuel combustion) in Greece in 1997 to that in 1999?
Ensure brevity in your answer.  1.04. What is the ratio of the CO2 emissions (% of total fuel combustion) in Yemen, Rep. in 1997 to that in 1999?
Your answer should be compact. 0.9. What is the ratio of the CO2 emissions (% of total fuel combustion) in Lower middle income in 1997 to that in 2000?
Offer a very short reply. 1.1. What is the ratio of the CO2 emissions (% of total fuel combustion) of France in 1997 to that in 2000?
Ensure brevity in your answer.  0.89. What is the ratio of the CO2 emissions (% of total fuel combustion) in Greece in 1997 to that in 2000?
Keep it short and to the point. 1.14. What is the ratio of the CO2 emissions (% of total fuel combustion) in Yemen, Rep. in 1997 to that in 2000?
Offer a very short reply. 0.82. What is the ratio of the CO2 emissions (% of total fuel combustion) of Lower middle income in 1997 to that in 2001?
Provide a succinct answer. 1.1. What is the ratio of the CO2 emissions (% of total fuel combustion) in France in 1997 to that in 2001?
Ensure brevity in your answer.  0.88. What is the ratio of the CO2 emissions (% of total fuel combustion) of Greece in 1997 to that in 2001?
Your response must be concise. 1.15. What is the ratio of the CO2 emissions (% of total fuel combustion) of Yemen, Rep. in 1997 to that in 2001?
Make the answer very short. 0.8. What is the ratio of the CO2 emissions (% of total fuel combustion) of Lower middle income in 1998 to that in 1999?
Offer a very short reply. 0.98. What is the ratio of the CO2 emissions (% of total fuel combustion) in France in 1998 to that in 1999?
Provide a short and direct response. 0.99. What is the ratio of the CO2 emissions (% of total fuel combustion) of Yemen, Rep. in 1998 to that in 1999?
Give a very brief answer. 0.97. What is the ratio of the CO2 emissions (% of total fuel combustion) of Lower middle income in 1998 to that in 2000?
Keep it short and to the point. 0.98. What is the ratio of the CO2 emissions (% of total fuel combustion) in Greece in 1998 to that in 2000?
Make the answer very short. 1.09. What is the ratio of the CO2 emissions (% of total fuel combustion) of Yemen, Rep. in 1998 to that in 2000?
Give a very brief answer. 0.88. What is the ratio of the CO2 emissions (% of total fuel combustion) in Lower middle income in 1998 to that in 2001?
Your response must be concise. 0.98. What is the ratio of the CO2 emissions (% of total fuel combustion) of France in 1998 to that in 2001?
Ensure brevity in your answer.  0.97. What is the ratio of the CO2 emissions (% of total fuel combustion) of Greece in 1998 to that in 2001?
Your response must be concise. 1.1. What is the ratio of the CO2 emissions (% of total fuel combustion) of Yemen, Rep. in 1998 to that in 2001?
Offer a very short reply. 0.86. What is the ratio of the CO2 emissions (% of total fuel combustion) in Lower middle income in 1999 to that in 2000?
Provide a succinct answer. 0.99. What is the ratio of the CO2 emissions (% of total fuel combustion) of Greece in 1999 to that in 2000?
Provide a short and direct response. 1.09. What is the ratio of the CO2 emissions (% of total fuel combustion) in Yemen, Rep. in 1999 to that in 2000?
Offer a terse response. 0.91. What is the ratio of the CO2 emissions (% of total fuel combustion) of France in 1999 to that in 2001?
Provide a succinct answer. 0.98. What is the ratio of the CO2 emissions (% of total fuel combustion) of Greece in 1999 to that in 2001?
Offer a very short reply. 1.1. What is the ratio of the CO2 emissions (% of total fuel combustion) in Yemen, Rep. in 1999 to that in 2001?
Offer a terse response. 0.89. What is the ratio of the CO2 emissions (% of total fuel combustion) in France in 2000 to that in 2001?
Offer a very short reply. 1. What is the ratio of the CO2 emissions (% of total fuel combustion) of Greece in 2000 to that in 2001?
Provide a succinct answer. 1.01. What is the ratio of the CO2 emissions (% of total fuel combustion) of Yemen, Rep. in 2000 to that in 2001?
Your answer should be compact. 0.98. What is the difference between the highest and the second highest CO2 emissions (% of total fuel combustion) in Lower middle income?
Ensure brevity in your answer.  0.02. What is the difference between the highest and the second highest CO2 emissions (% of total fuel combustion) in France?
Ensure brevity in your answer.  0.02. What is the difference between the highest and the second highest CO2 emissions (% of total fuel combustion) in Greece?
Provide a succinct answer. 0.05. What is the difference between the highest and the second highest CO2 emissions (% of total fuel combustion) of Yemen, Rep.?
Keep it short and to the point. 0.28. What is the difference between the highest and the lowest CO2 emissions (% of total fuel combustion) of Lower middle income?
Keep it short and to the point. 0.42. What is the difference between the highest and the lowest CO2 emissions (% of total fuel combustion) in France?
Offer a very short reply. 0.47. What is the difference between the highest and the lowest CO2 emissions (% of total fuel combustion) of Greece?
Ensure brevity in your answer.  0.48. What is the difference between the highest and the lowest CO2 emissions (% of total fuel combustion) of Yemen, Rep.?
Your answer should be compact. 3.77. 